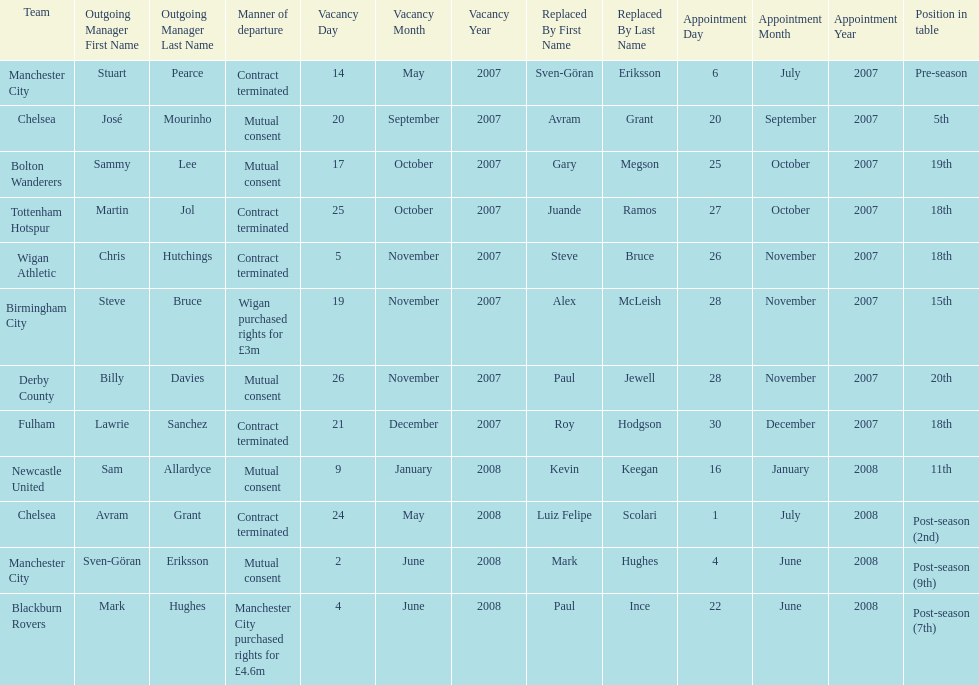Avram grant was with chelsea for at least how many years? 1. 